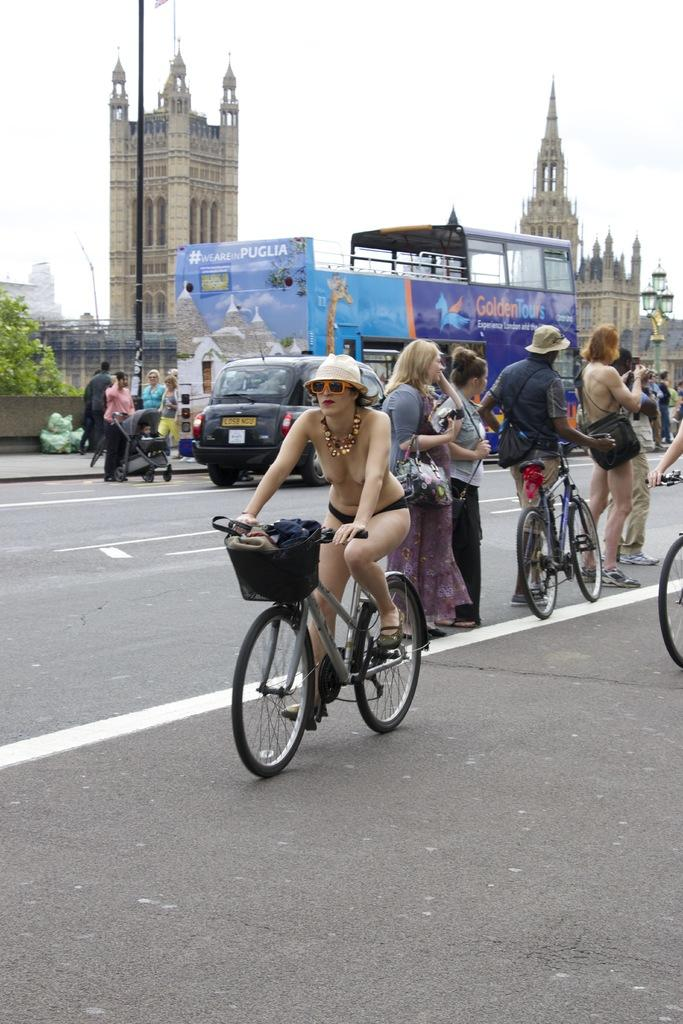What is the condition of the sky in the image? The sky is clear in the image. What type of structures can be seen in the image? There are buildings in the image. What are the people in the image doing? People are standing on the road in the image. Is there any form of transportation visible in the image? Yes, a person is riding a bicycle on the road in the image. What type of line or curve can be seen in the image? There is no specific line or curve mentioned in the provided facts. The image primarily features buildings, a clear sky, people standing on the road, and a person riding a bicycle. 